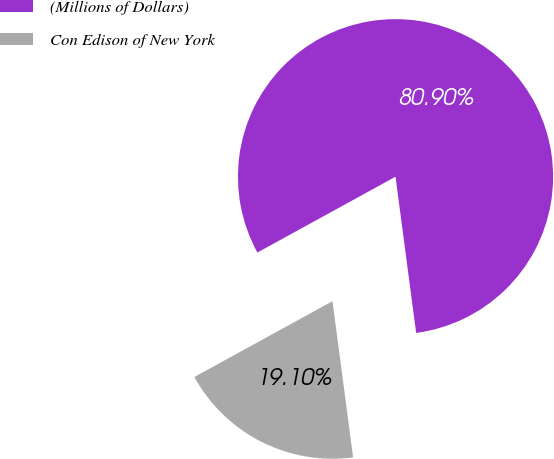Convert chart. <chart><loc_0><loc_0><loc_500><loc_500><pie_chart><fcel>(Millions of Dollars)<fcel>Con Edison of New York<nl><fcel>80.9%<fcel>19.1%<nl></chart> 